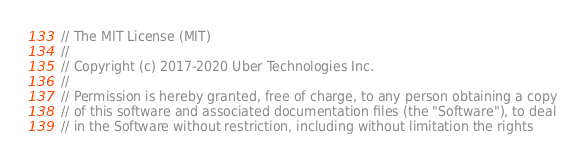<code> <loc_0><loc_0><loc_500><loc_500><_Go_>// The MIT License (MIT)
//
// Copyright (c) 2017-2020 Uber Technologies Inc.
//
// Permission is hereby granted, free of charge, to any person obtaining a copy
// of this software and associated documentation files (the "Software"), to deal
// in the Software without restriction, including without limitation the rights</code> 